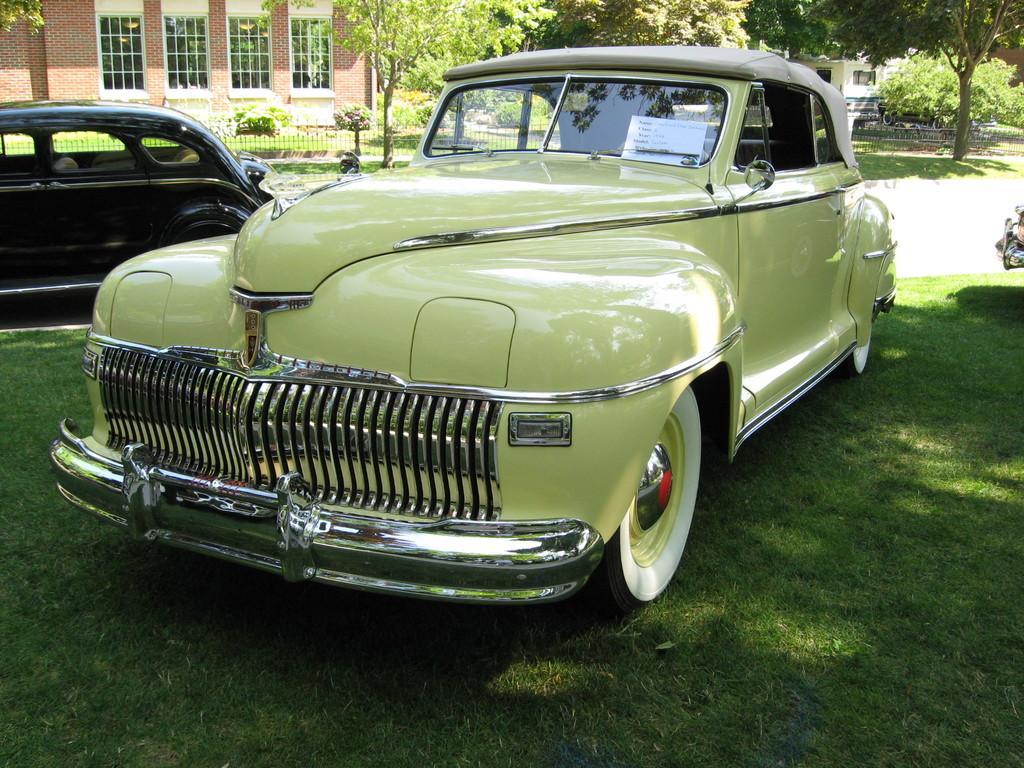Could you give a brief overview of what you see in this image? In this image we can see some cars parked on the ground. We can also see some grass, a group of trees, plants, a fence and a building with windows. 